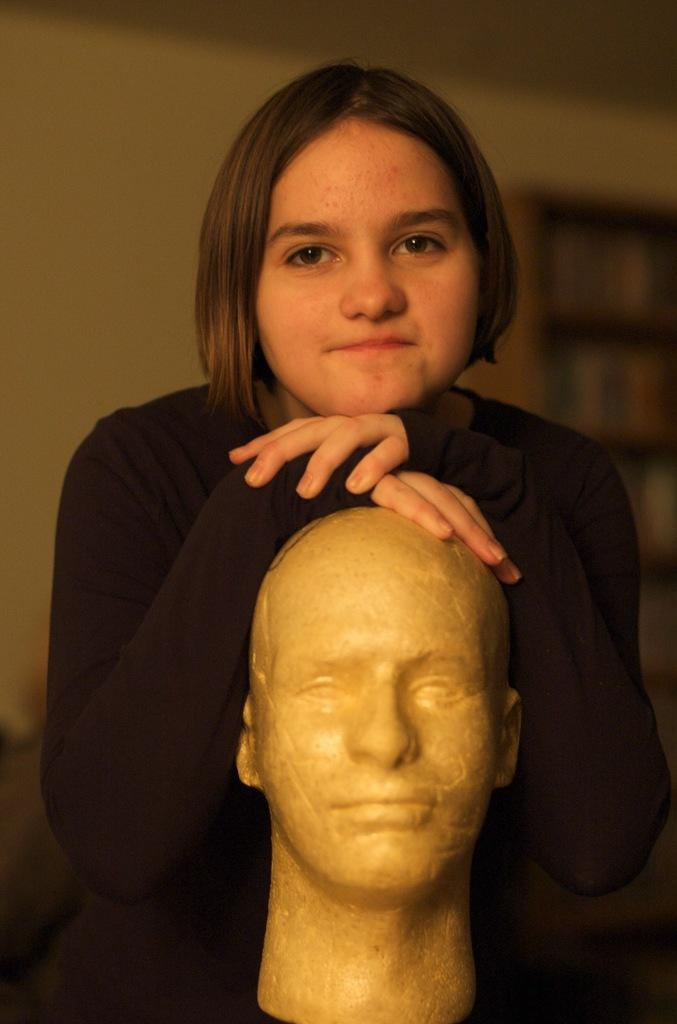Who is the main subject in the image? There is a girl in the image. What is the girl doing in the image? The girl is standing and putting her hands on the head of a statue. What can be seen in the background of the image? There is a wall in the background of the image. What type of beef is being served on a plate in the image? There is no beef or plate present in the image; it features a girl standing and interacting with a statue. 